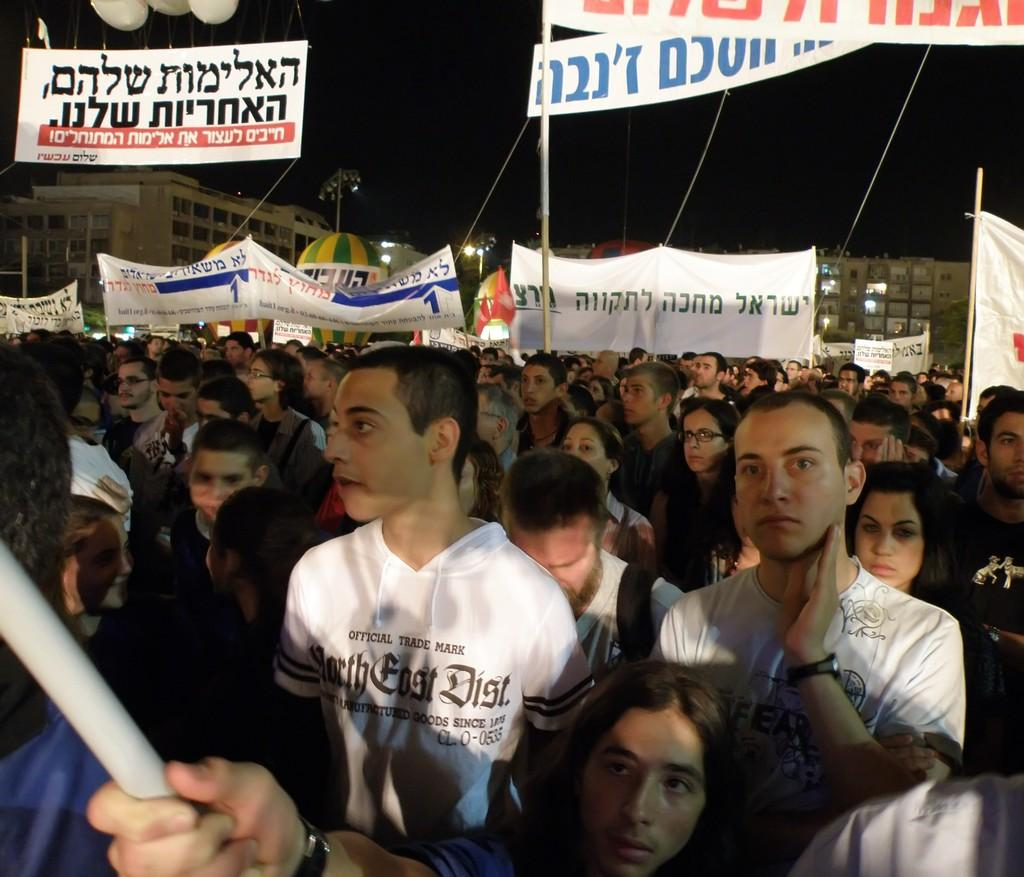What is located in the foreground of the picture? There are people in the foreground of the picture. What can be seen in the middle of the picture? There are banners and people in the middle of the picture. What is visible in the background of the picture? There are buildings in the background of the picture. What is visible at the top of the image? The sky is visible at the top of the image. What type of glass is being used to paint the cakes in the image? There are no cakes or glass present in the image; it features people, banners, and buildings. 